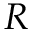Convert formula to latex. <formula><loc_0><loc_0><loc_500><loc_500>R</formula> 